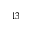Convert formula to latex. <formula><loc_0><loc_0><loc_500><loc_500>^ { 1 3 }</formula> 